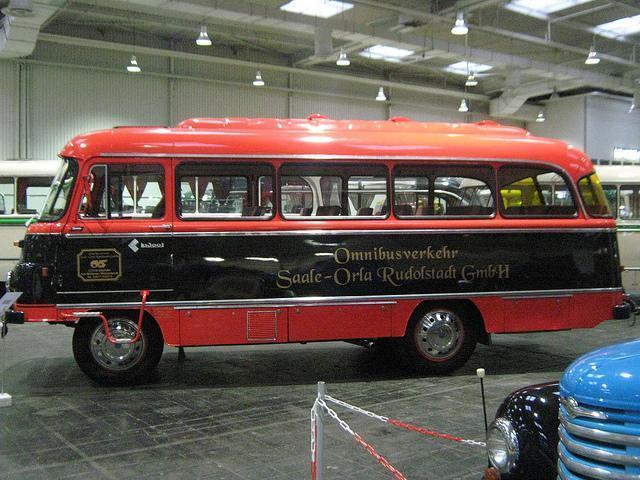How many buses are in the picture?
Give a very brief answer. 1. 